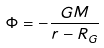<formula> <loc_0><loc_0><loc_500><loc_500>\Phi = - \frac { G M } { r - R _ { G } }</formula> 